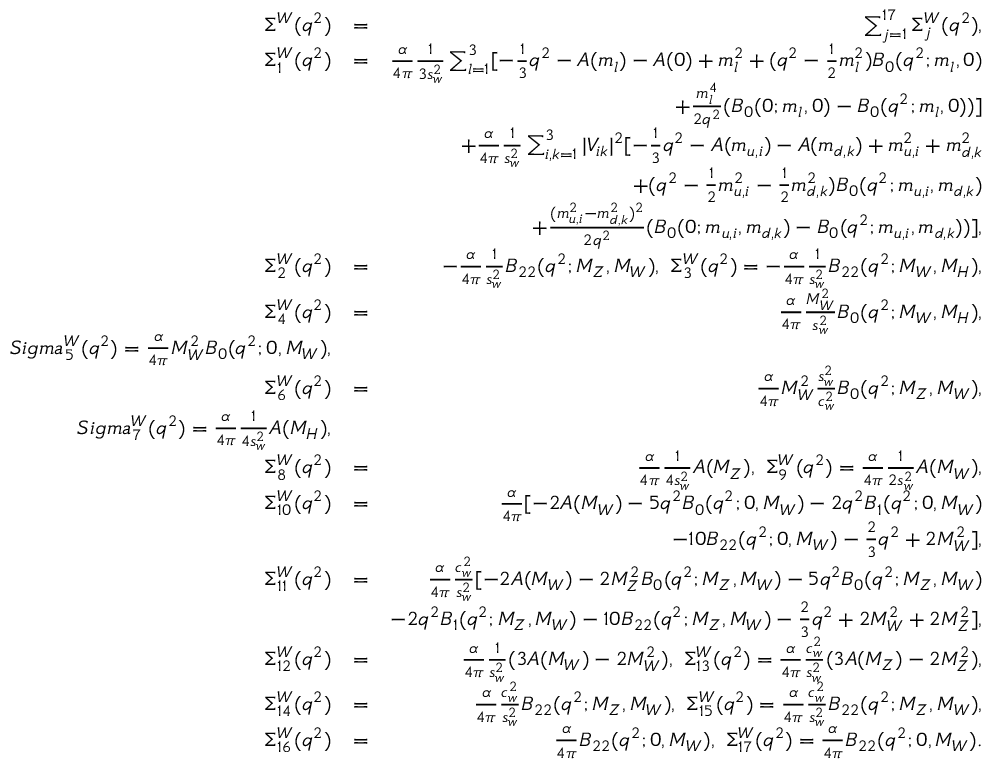<formula> <loc_0><loc_0><loc_500><loc_500>\begin{array} { r l r } { \Sigma ^ { W } ( q ^ { 2 } ) } & { = } & { \sum _ { j = 1 } ^ { 1 7 } \Sigma _ { j } ^ { W } ( q ^ { 2 } ) , } \\ { \Sigma _ { 1 } ^ { W } ( q ^ { 2 } ) } & { = } & { \frac { \alpha } { 4 \pi } \frac { 1 } { 3 s _ { w } ^ { 2 } } \sum _ { l = 1 } ^ { 3 } [ - \frac { 1 } { 3 } q ^ { 2 } - A ( m _ { l } ) - A ( 0 ) + m _ { l } ^ { 2 } + ( q ^ { 2 } - \frac { 1 } { 2 } m _ { l } ^ { 2 } ) B _ { 0 } ( q ^ { 2 } ; m _ { l } , 0 ) } \\ & { + \frac { m _ { l } ^ { 4 } } { 2 q ^ { 2 } } ( B _ { 0 } ( 0 ; m _ { l } , 0 ) - B _ { 0 } ( q ^ { 2 } ; m _ { l } , 0 ) ) ] } \\ & { + \frac { \alpha } { 4 \pi } \frac { 1 } { s _ { w } ^ { 2 } } \sum _ { i , k = 1 } ^ { 3 } | V _ { i k } | ^ { 2 } [ - \frac { 1 } { 3 } q ^ { 2 } - A ( m _ { u , i } ) - A ( m _ { d , k } ) + m _ { u , i } ^ { 2 } + m _ { d , k } ^ { 2 } } \\ & { + ( q ^ { 2 } - \frac { 1 } { 2 } m _ { u , i } ^ { 2 } - \frac { 1 } { 2 } m _ { d , k } ^ { 2 } ) B _ { 0 } ( q ^ { 2 } ; m _ { u , i } , m _ { d , k } ) } \\ & { + \frac { ( m _ { u , i } ^ { 2 } - m _ { d , k } ^ { 2 } ) ^ { 2 } } { 2 q ^ { 2 } } ( B _ { 0 } ( 0 ; m _ { u , i } , m _ { d , k } ) - B _ { 0 } ( q ^ { 2 } ; m _ { u , i } , m _ { d , k } ) ) ] , } \\ { \Sigma _ { 2 } ^ { W } ( q ^ { 2 } ) } & { = } & { - \frac { \alpha } { 4 \pi } \frac { 1 } { s _ { w } ^ { 2 } } B _ { 2 2 } ( q ^ { 2 } ; M _ { Z } , M _ { W } ) , \ \Sigma _ { 3 } ^ { W } ( q ^ { 2 } ) = - \frac { \alpha } { 4 \pi } \frac { 1 } { s _ { w } ^ { 2 } } B _ { 2 2 } ( q ^ { 2 } ; M _ { W } , M _ { H } ) , } \\ { \Sigma _ { 4 } ^ { W } ( q ^ { 2 } ) } & { = } & { \frac { \alpha } { 4 \pi } \frac { M _ { W } ^ { 2 } } { s _ { w } ^ { 2 } } B _ { 0 } ( q ^ { 2 } ; M _ { W } , M _ { H } ) , } \\ { S i g m a _ { 5 } ^ { W } ( q ^ { 2 } ) = \frac { \alpha } { 4 \pi } M _ { W } ^ { 2 } B _ { 0 } ( q ^ { 2 } ; 0 , M _ { W } ) , } \\ { \Sigma _ { 6 } ^ { W } ( q ^ { 2 } ) } & { = } & { \frac { \alpha } { 4 \pi } M _ { W } ^ { 2 } \frac { s _ { w } ^ { 2 } } { c _ { w } ^ { 2 } } B _ { 0 } ( q ^ { 2 } ; M _ { Z } , M _ { W } ) , } \\ { S i g m a _ { 7 } ^ { W } ( q ^ { 2 } ) = \frac { \alpha } { 4 \pi } \frac { 1 } { 4 s _ { w } ^ { 2 } } A ( M _ { H } ) , } \\ { \Sigma _ { 8 } ^ { W } ( q ^ { 2 } ) } & { = } & { \frac { \alpha } { 4 \pi } \frac { 1 } { 4 s _ { w } ^ { 2 } } A ( M _ { Z } ) , \ \Sigma _ { 9 } ^ { W } ( q ^ { 2 } ) = \frac { \alpha } { 4 \pi } \frac { 1 } { 2 s _ { w } ^ { 2 } } A ( M _ { W } ) , } \\ { \Sigma _ { 1 0 } ^ { W } ( q ^ { 2 } ) } & { = } & { \frac { \alpha } { 4 \pi } [ - 2 A ( M _ { W } ) - 5 q ^ { 2 } B _ { 0 } ( q ^ { 2 } ; 0 , M _ { W } ) - 2 q ^ { 2 } B _ { 1 } ( q ^ { 2 } ; 0 , M _ { W } ) } \\ & { - 1 0 B _ { 2 2 } ( q ^ { 2 } ; 0 , M _ { W } ) - \frac { 2 } { 3 } q ^ { 2 } + 2 M _ { W } ^ { 2 } ] , } \\ { \Sigma _ { 1 1 } ^ { W } ( q ^ { 2 } ) } & { = } & { \frac { \alpha } { 4 \pi } \frac { c _ { w } ^ { 2 } } { s _ { w } ^ { 2 } } [ - 2 A ( M _ { W } ) - 2 M _ { Z } ^ { 2 } B _ { 0 } ( q ^ { 2 } ; M _ { Z } , M _ { W } ) - 5 q ^ { 2 } B _ { 0 } ( q ^ { 2 } ; M _ { Z } , M _ { W } ) } \\ & { - 2 q ^ { 2 } B _ { 1 } ( q ^ { 2 } ; M _ { Z } , M _ { W } ) - 1 0 B _ { 2 2 } ( q ^ { 2 } ; M _ { Z } , M _ { W } ) - \frac { 2 } { 3 } q ^ { 2 } + 2 M _ { W } ^ { 2 } + 2 M _ { Z } ^ { 2 } ] , } \\ { \Sigma _ { 1 2 } ^ { W } ( q ^ { 2 } ) } & { = } & { \frac { \alpha } { 4 \pi } \frac { 1 } { s _ { w } ^ { 2 } } ( 3 A ( M _ { W } ) - 2 M _ { W } ^ { 2 } ) , \ \Sigma _ { 1 3 } ^ { W } ( q ^ { 2 } ) = \frac { \alpha } { 4 \pi } \frac { c _ { w } ^ { 2 } } { s _ { w } ^ { 2 } } ( 3 A ( M _ { Z } ) - 2 M _ { Z } ^ { 2 } ) , } \\ { \Sigma _ { 1 4 } ^ { W } ( q ^ { 2 } ) } & { = } & { \frac { \alpha } { 4 \pi } \frac { c _ { w } ^ { 2 } } { s _ { w } ^ { 2 } } B _ { 2 2 } ( q ^ { 2 } ; M _ { Z } , M _ { W } ) , \ \Sigma _ { 1 5 } ^ { W } ( q ^ { 2 } ) = \frac { \alpha } { 4 \pi } \frac { c _ { w } ^ { 2 } } { s _ { w } ^ { 2 } } B _ { 2 2 } ( q ^ { 2 } ; M _ { Z } , M _ { W } ) , } \\ { \Sigma _ { 1 6 } ^ { W } ( q ^ { 2 } ) } & { = } & { \frac { \alpha } { 4 \pi } B _ { 2 2 } ( q ^ { 2 } ; 0 , M _ { W } ) , \ \Sigma _ { 1 7 } ^ { W } ( q ^ { 2 } ) = \frac { \alpha } { 4 \pi } B _ { 2 2 } ( q ^ { 2 } ; 0 , M _ { W } ) . } \end{array}</formula> 